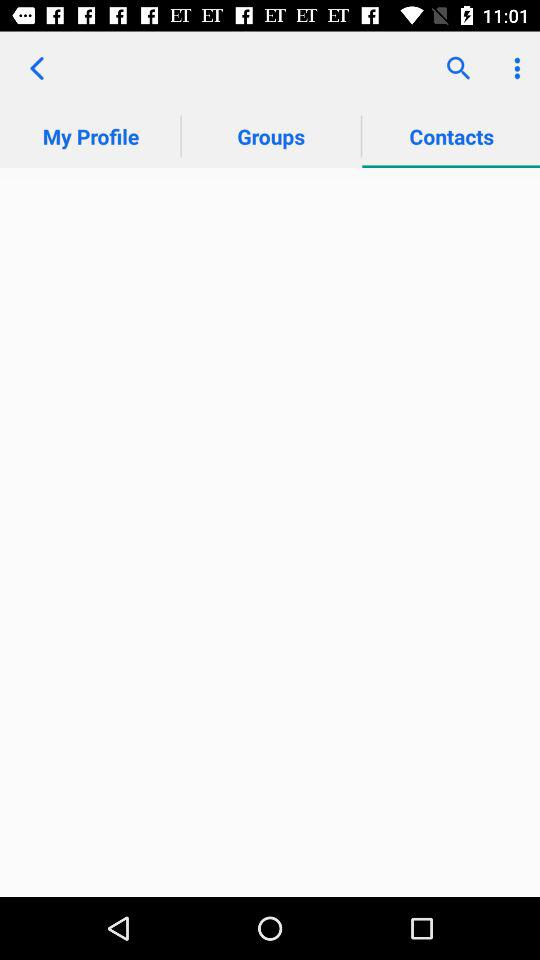What is the selected option? The selected option is "Contacts". 